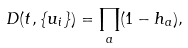<formula> <loc_0><loc_0><loc_500><loc_500>D ( t , \{ u _ { i } \} ) = \prod _ { a } ( 1 - h _ { a } ) ,</formula> 